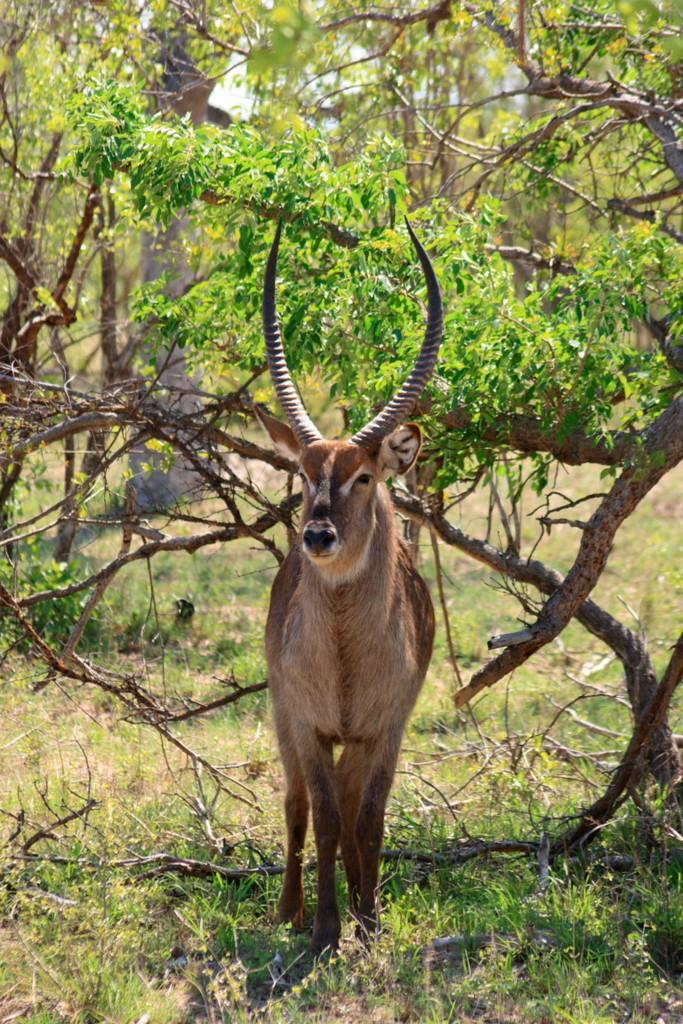What is the main subject in the center of the image? There is an animal in the center of the image. What type of vegetation is visible at the bottom of the image? There is grass at the bottom of the image. What can be seen in the background of the image? There are trees in the background of the image. How many fangs does the animal have in the image? There is no information about the animal's fangs in the image, so it cannot be determined. 